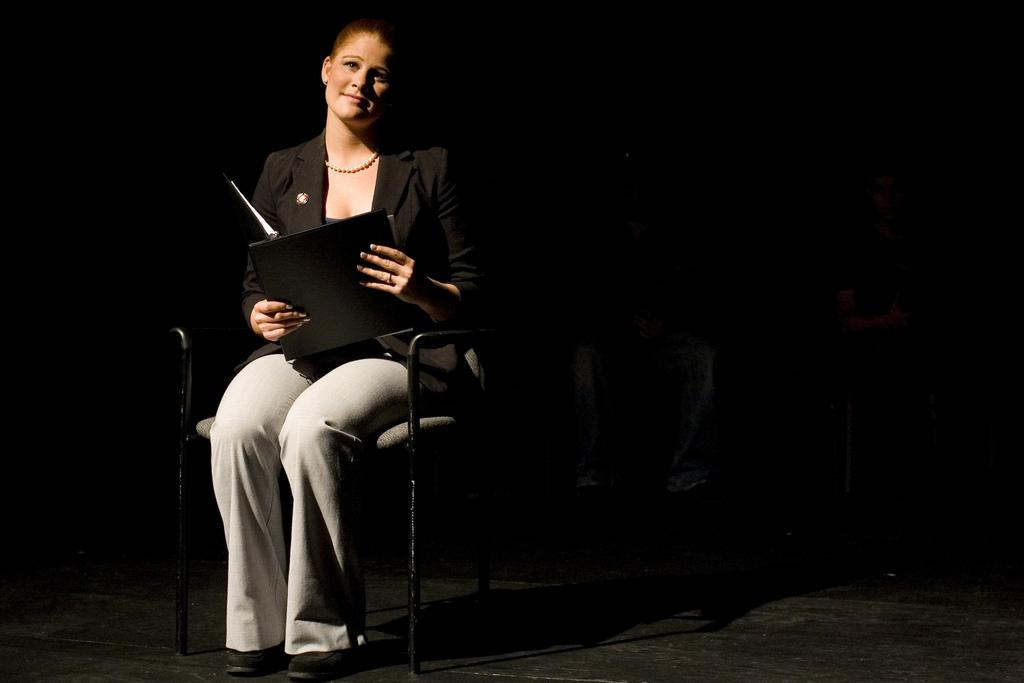Who is the main subject in the image? There is a woman in the image. What is the woman doing in the image? The woman is sitting on a chair. What is the woman wearing around her neck? The woman is wearing a necklace. What color is the jacket the woman is wearing? The woman is wearing a black color jacket. What color are the pants the woman is wearing? The woman is wearing white color pants. What can be observed about the background of the image? The background of the image is dark. What type of crack can be heard in the background of the image? There is no sound, such as a crack, present in the image. The image is a still photograph, and no audio is associated with it. 